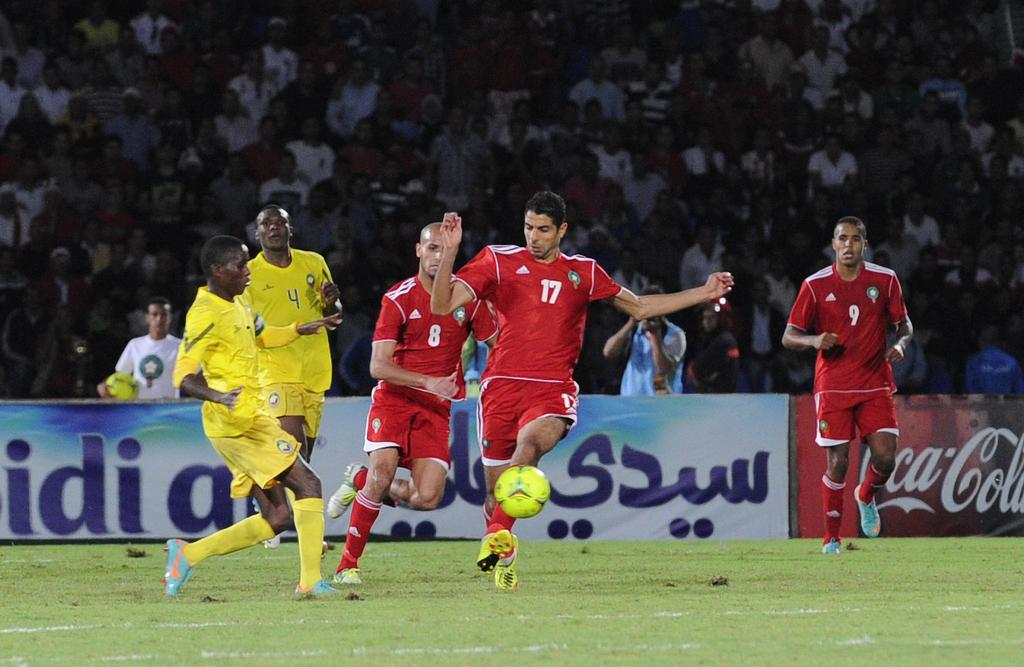Provide a one-sentence caption for the provided image. Players race down the field near a sign for Coca Cola. 